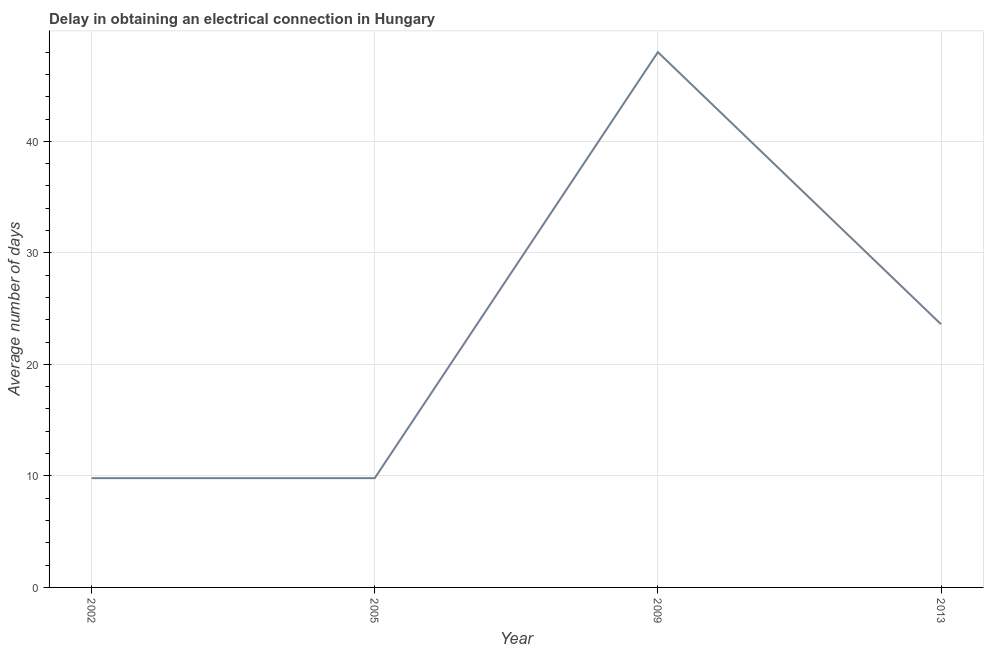What is the dalay in electrical connection in 2013?
Your answer should be compact. 23.6. In which year was the dalay in electrical connection maximum?
Your answer should be compact. 2009. What is the sum of the dalay in electrical connection?
Give a very brief answer. 91.2. What is the difference between the dalay in electrical connection in 2005 and 2009?
Provide a succinct answer. -38.2. What is the average dalay in electrical connection per year?
Your answer should be compact. 22.8. What is the median dalay in electrical connection?
Provide a short and direct response. 16.7. What is the ratio of the dalay in electrical connection in 2002 to that in 2009?
Your response must be concise. 0.2. Is the difference between the dalay in electrical connection in 2009 and 2013 greater than the difference between any two years?
Keep it short and to the point. No. What is the difference between the highest and the second highest dalay in electrical connection?
Give a very brief answer. 24.4. Is the sum of the dalay in electrical connection in 2002 and 2009 greater than the maximum dalay in electrical connection across all years?
Ensure brevity in your answer.  Yes. What is the difference between the highest and the lowest dalay in electrical connection?
Ensure brevity in your answer.  38.2. In how many years, is the dalay in electrical connection greater than the average dalay in electrical connection taken over all years?
Ensure brevity in your answer.  2. Does the dalay in electrical connection monotonically increase over the years?
Ensure brevity in your answer.  No. How many lines are there?
Your answer should be very brief. 1. How many years are there in the graph?
Offer a very short reply. 4. What is the difference between two consecutive major ticks on the Y-axis?
Offer a terse response. 10. Are the values on the major ticks of Y-axis written in scientific E-notation?
Offer a terse response. No. What is the title of the graph?
Offer a terse response. Delay in obtaining an electrical connection in Hungary. What is the label or title of the Y-axis?
Keep it short and to the point. Average number of days. What is the Average number of days in 2005?
Ensure brevity in your answer.  9.8. What is the Average number of days in 2009?
Offer a terse response. 48. What is the Average number of days in 2013?
Provide a succinct answer. 23.6. What is the difference between the Average number of days in 2002 and 2005?
Your answer should be very brief. 0. What is the difference between the Average number of days in 2002 and 2009?
Keep it short and to the point. -38.2. What is the difference between the Average number of days in 2002 and 2013?
Offer a terse response. -13.8. What is the difference between the Average number of days in 2005 and 2009?
Keep it short and to the point. -38.2. What is the difference between the Average number of days in 2009 and 2013?
Provide a short and direct response. 24.4. What is the ratio of the Average number of days in 2002 to that in 2005?
Offer a very short reply. 1. What is the ratio of the Average number of days in 2002 to that in 2009?
Your answer should be very brief. 0.2. What is the ratio of the Average number of days in 2002 to that in 2013?
Offer a very short reply. 0.41. What is the ratio of the Average number of days in 2005 to that in 2009?
Give a very brief answer. 0.2. What is the ratio of the Average number of days in 2005 to that in 2013?
Give a very brief answer. 0.41. What is the ratio of the Average number of days in 2009 to that in 2013?
Offer a terse response. 2.03. 